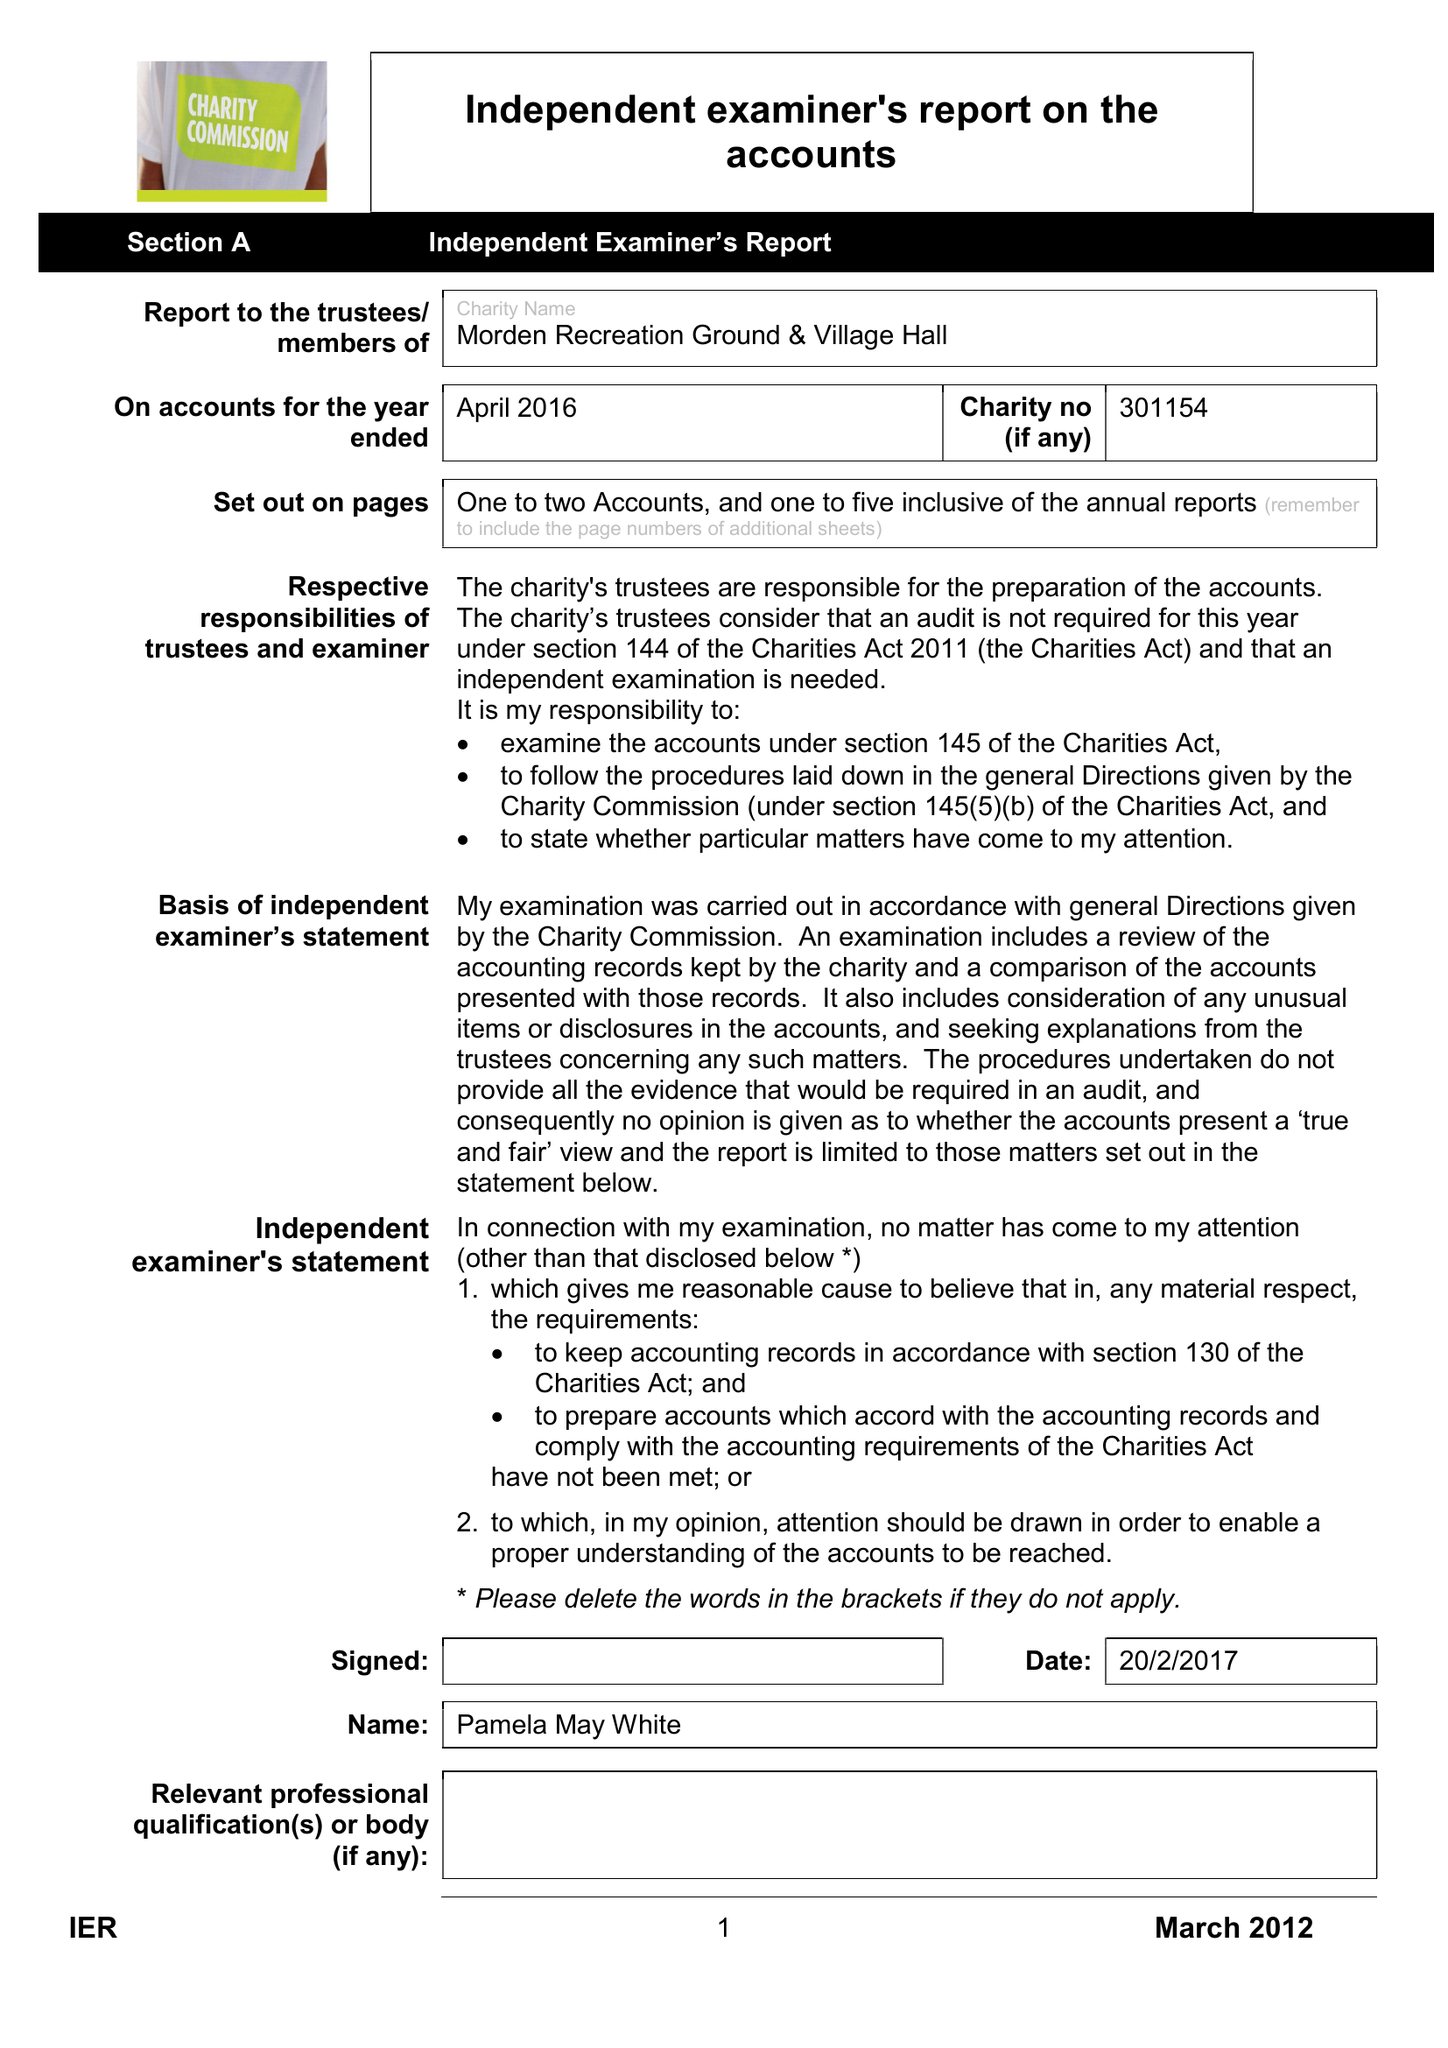What is the value for the address__street_line?
Answer the question using a single word or phrase. None 